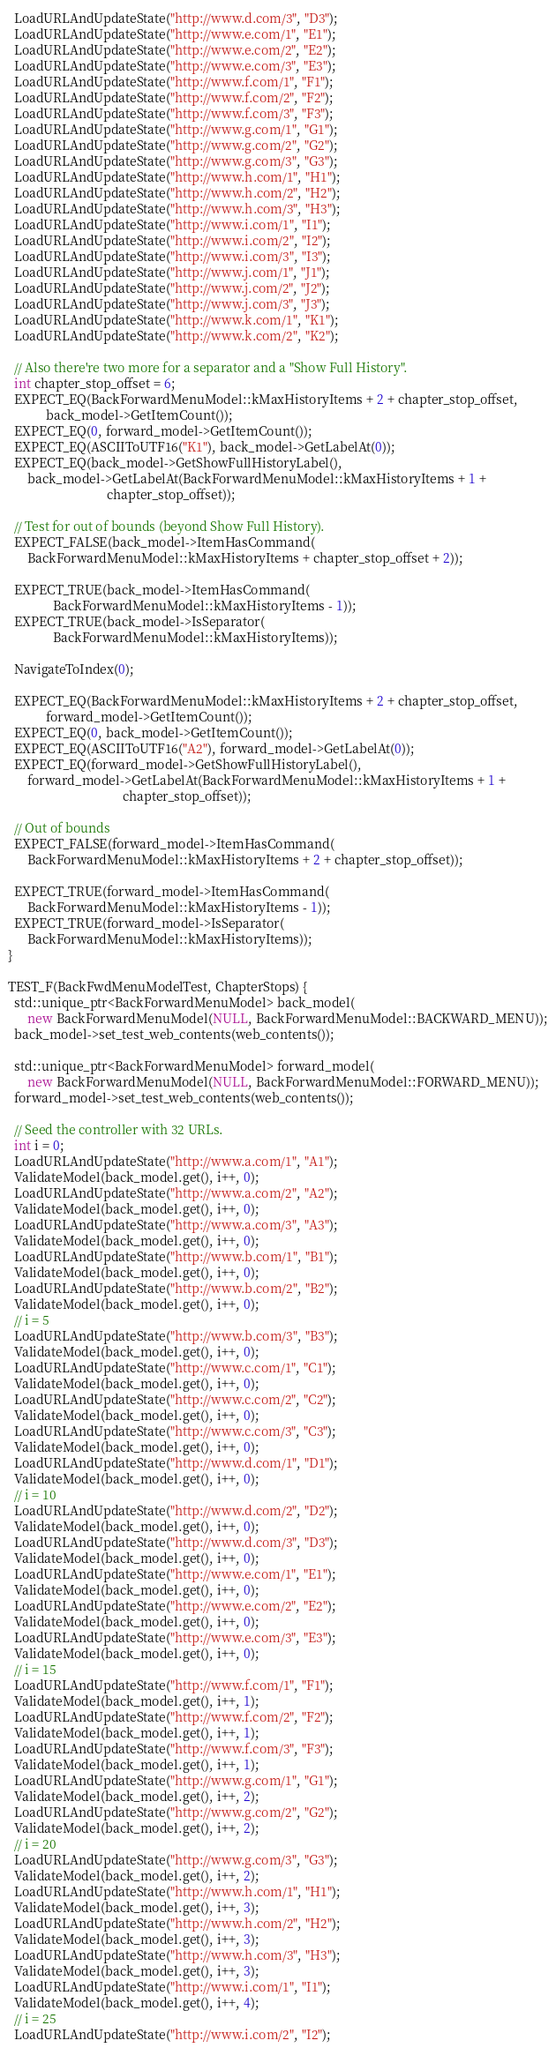Convert code to text. <code><loc_0><loc_0><loc_500><loc_500><_C++_>  LoadURLAndUpdateState("http://www.d.com/3", "D3");
  LoadURLAndUpdateState("http://www.e.com/1", "E1");
  LoadURLAndUpdateState("http://www.e.com/2", "E2");
  LoadURLAndUpdateState("http://www.e.com/3", "E3");
  LoadURLAndUpdateState("http://www.f.com/1", "F1");
  LoadURLAndUpdateState("http://www.f.com/2", "F2");
  LoadURLAndUpdateState("http://www.f.com/3", "F3");
  LoadURLAndUpdateState("http://www.g.com/1", "G1");
  LoadURLAndUpdateState("http://www.g.com/2", "G2");
  LoadURLAndUpdateState("http://www.g.com/3", "G3");
  LoadURLAndUpdateState("http://www.h.com/1", "H1");
  LoadURLAndUpdateState("http://www.h.com/2", "H2");
  LoadURLAndUpdateState("http://www.h.com/3", "H3");
  LoadURLAndUpdateState("http://www.i.com/1", "I1");
  LoadURLAndUpdateState("http://www.i.com/2", "I2");
  LoadURLAndUpdateState("http://www.i.com/3", "I3");
  LoadURLAndUpdateState("http://www.j.com/1", "J1");
  LoadURLAndUpdateState("http://www.j.com/2", "J2");
  LoadURLAndUpdateState("http://www.j.com/3", "J3");
  LoadURLAndUpdateState("http://www.k.com/1", "K1");
  LoadURLAndUpdateState("http://www.k.com/2", "K2");

  // Also there're two more for a separator and a "Show Full History".
  int chapter_stop_offset = 6;
  EXPECT_EQ(BackForwardMenuModel::kMaxHistoryItems + 2 + chapter_stop_offset,
            back_model->GetItemCount());
  EXPECT_EQ(0, forward_model->GetItemCount());
  EXPECT_EQ(ASCIIToUTF16("K1"), back_model->GetLabelAt(0));
  EXPECT_EQ(back_model->GetShowFullHistoryLabel(),
      back_model->GetLabelAt(BackForwardMenuModel::kMaxHistoryItems + 1 +
                               chapter_stop_offset));

  // Test for out of bounds (beyond Show Full History).
  EXPECT_FALSE(back_model->ItemHasCommand(
      BackForwardMenuModel::kMaxHistoryItems + chapter_stop_offset + 2));

  EXPECT_TRUE(back_model->ItemHasCommand(
              BackForwardMenuModel::kMaxHistoryItems - 1));
  EXPECT_TRUE(back_model->IsSeparator(
              BackForwardMenuModel::kMaxHistoryItems));

  NavigateToIndex(0);

  EXPECT_EQ(BackForwardMenuModel::kMaxHistoryItems + 2 + chapter_stop_offset,
            forward_model->GetItemCount());
  EXPECT_EQ(0, back_model->GetItemCount());
  EXPECT_EQ(ASCIIToUTF16("A2"), forward_model->GetLabelAt(0));
  EXPECT_EQ(forward_model->GetShowFullHistoryLabel(),
      forward_model->GetLabelAt(BackForwardMenuModel::kMaxHistoryItems + 1 +
                                    chapter_stop_offset));

  // Out of bounds
  EXPECT_FALSE(forward_model->ItemHasCommand(
      BackForwardMenuModel::kMaxHistoryItems + 2 + chapter_stop_offset));

  EXPECT_TRUE(forward_model->ItemHasCommand(
      BackForwardMenuModel::kMaxHistoryItems - 1));
  EXPECT_TRUE(forward_model->IsSeparator(
      BackForwardMenuModel::kMaxHistoryItems));
}

TEST_F(BackFwdMenuModelTest, ChapterStops) {
  std::unique_ptr<BackForwardMenuModel> back_model(
      new BackForwardMenuModel(NULL, BackForwardMenuModel::BACKWARD_MENU));
  back_model->set_test_web_contents(web_contents());

  std::unique_ptr<BackForwardMenuModel> forward_model(
      new BackForwardMenuModel(NULL, BackForwardMenuModel::FORWARD_MENU));
  forward_model->set_test_web_contents(web_contents());

  // Seed the controller with 32 URLs.
  int i = 0;
  LoadURLAndUpdateState("http://www.a.com/1", "A1");
  ValidateModel(back_model.get(), i++, 0);
  LoadURLAndUpdateState("http://www.a.com/2", "A2");
  ValidateModel(back_model.get(), i++, 0);
  LoadURLAndUpdateState("http://www.a.com/3", "A3");
  ValidateModel(back_model.get(), i++, 0);
  LoadURLAndUpdateState("http://www.b.com/1", "B1");
  ValidateModel(back_model.get(), i++, 0);
  LoadURLAndUpdateState("http://www.b.com/2", "B2");
  ValidateModel(back_model.get(), i++, 0);
  // i = 5
  LoadURLAndUpdateState("http://www.b.com/3", "B3");
  ValidateModel(back_model.get(), i++, 0);
  LoadURLAndUpdateState("http://www.c.com/1", "C1");
  ValidateModel(back_model.get(), i++, 0);
  LoadURLAndUpdateState("http://www.c.com/2", "C2");
  ValidateModel(back_model.get(), i++, 0);
  LoadURLAndUpdateState("http://www.c.com/3", "C3");
  ValidateModel(back_model.get(), i++, 0);
  LoadURLAndUpdateState("http://www.d.com/1", "D1");
  ValidateModel(back_model.get(), i++, 0);
  // i = 10
  LoadURLAndUpdateState("http://www.d.com/2", "D2");
  ValidateModel(back_model.get(), i++, 0);
  LoadURLAndUpdateState("http://www.d.com/3", "D3");
  ValidateModel(back_model.get(), i++, 0);
  LoadURLAndUpdateState("http://www.e.com/1", "E1");
  ValidateModel(back_model.get(), i++, 0);
  LoadURLAndUpdateState("http://www.e.com/2", "E2");
  ValidateModel(back_model.get(), i++, 0);
  LoadURLAndUpdateState("http://www.e.com/3", "E3");
  ValidateModel(back_model.get(), i++, 0);
  // i = 15
  LoadURLAndUpdateState("http://www.f.com/1", "F1");
  ValidateModel(back_model.get(), i++, 1);
  LoadURLAndUpdateState("http://www.f.com/2", "F2");
  ValidateModel(back_model.get(), i++, 1);
  LoadURLAndUpdateState("http://www.f.com/3", "F3");
  ValidateModel(back_model.get(), i++, 1);
  LoadURLAndUpdateState("http://www.g.com/1", "G1");
  ValidateModel(back_model.get(), i++, 2);
  LoadURLAndUpdateState("http://www.g.com/2", "G2");
  ValidateModel(back_model.get(), i++, 2);
  // i = 20
  LoadURLAndUpdateState("http://www.g.com/3", "G3");
  ValidateModel(back_model.get(), i++, 2);
  LoadURLAndUpdateState("http://www.h.com/1", "H1");
  ValidateModel(back_model.get(), i++, 3);
  LoadURLAndUpdateState("http://www.h.com/2", "H2");
  ValidateModel(back_model.get(), i++, 3);
  LoadURLAndUpdateState("http://www.h.com/3", "H3");
  ValidateModel(back_model.get(), i++, 3);
  LoadURLAndUpdateState("http://www.i.com/1", "I1");
  ValidateModel(back_model.get(), i++, 4);
  // i = 25
  LoadURLAndUpdateState("http://www.i.com/2", "I2");</code> 